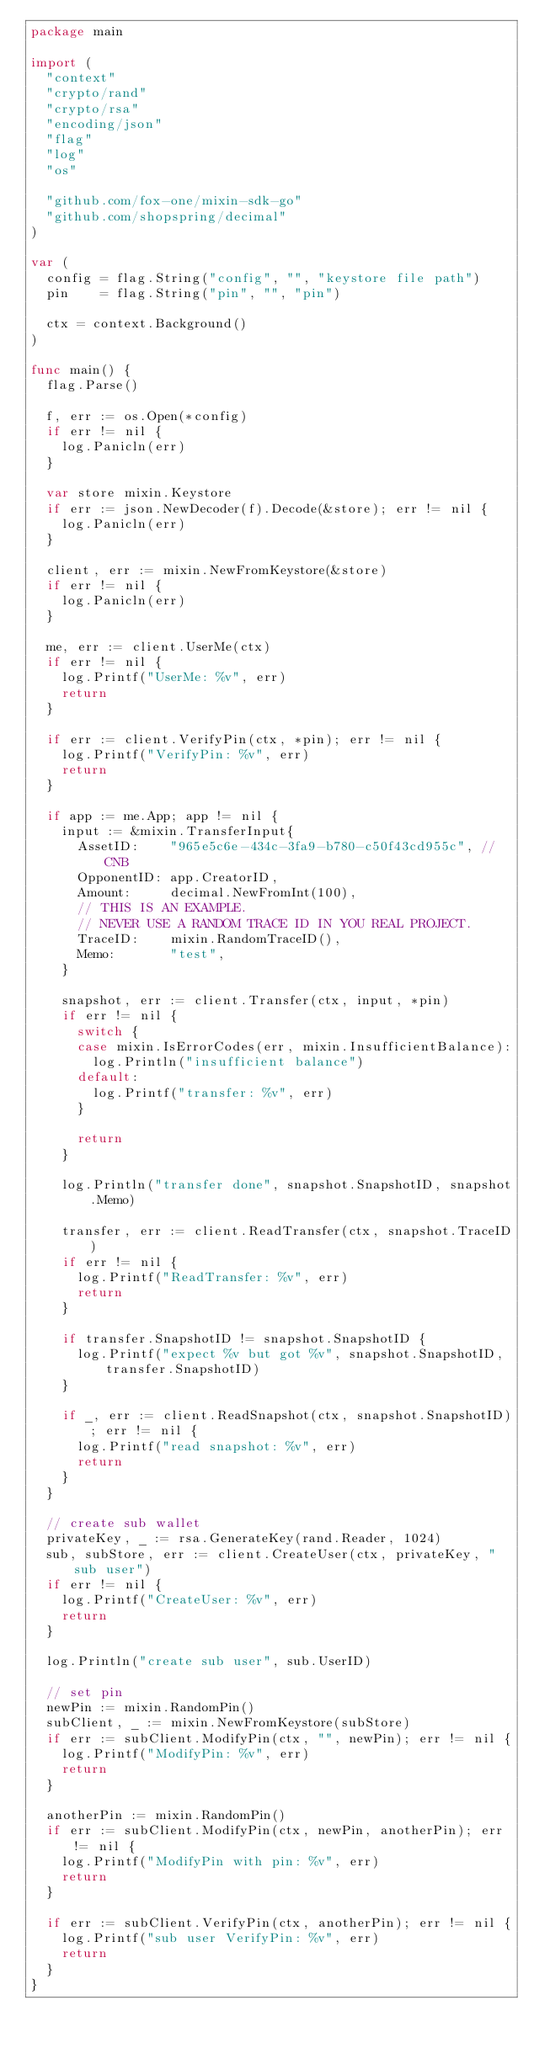<code> <loc_0><loc_0><loc_500><loc_500><_Go_>package main

import (
	"context"
	"crypto/rand"
	"crypto/rsa"
	"encoding/json"
	"flag"
	"log"
	"os"

	"github.com/fox-one/mixin-sdk-go"
	"github.com/shopspring/decimal"
)

var (
	config = flag.String("config", "", "keystore file path")
	pin    = flag.String("pin", "", "pin")

	ctx = context.Background()
)

func main() {
	flag.Parse()

	f, err := os.Open(*config)
	if err != nil {
		log.Panicln(err)
	}

	var store mixin.Keystore
	if err := json.NewDecoder(f).Decode(&store); err != nil {
		log.Panicln(err)
	}

	client, err := mixin.NewFromKeystore(&store)
	if err != nil {
		log.Panicln(err)
	}

	me, err := client.UserMe(ctx)
	if err != nil {
		log.Printf("UserMe: %v", err)
		return
	}

	if err := client.VerifyPin(ctx, *pin); err != nil {
		log.Printf("VerifyPin: %v", err)
		return
	}

	if app := me.App; app != nil {
		input := &mixin.TransferInput{
			AssetID:    "965e5c6e-434c-3fa9-b780-c50f43cd955c", // CNB
			OpponentID: app.CreatorID,
			Amount:     decimal.NewFromInt(100),
			// THIS IS AN EXAMPLE.
			// NEVER USE A RANDOM TRACE ID IN YOU REAL PROJECT.
			TraceID:    mixin.RandomTraceID(),
			Memo:       "test",
		}

		snapshot, err := client.Transfer(ctx, input, *pin)
		if err != nil {
			switch {
			case mixin.IsErrorCodes(err, mixin.InsufficientBalance):
				log.Println("insufficient balance")
			default:
				log.Printf("transfer: %v", err)
			}

			return
		}

		log.Println("transfer done", snapshot.SnapshotID, snapshot.Memo)

		transfer, err := client.ReadTransfer(ctx, snapshot.TraceID)
		if err != nil {
			log.Printf("ReadTransfer: %v", err)
			return
		}

		if transfer.SnapshotID != snapshot.SnapshotID {
			log.Printf("expect %v but got %v", snapshot.SnapshotID, transfer.SnapshotID)
		}

		if _, err := client.ReadSnapshot(ctx, snapshot.SnapshotID); err != nil {
			log.Printf("read snapshot: %v", err)
			return
		}
	}

	// create sub wallet
	privateKey, _ := rsa.GenerateKey(rand.Reader, 1024)
	sub, subStore, err := client.CreateUser(ctx, privateKey, "sub user")
	if err != nil {
		log.Printf("CreateUser: %v", err)
		return
	}

	log.Println("create sub user", sub.UserID)

	// set pin
	newPin := mixin.RandomPin()
	subClient, _ := mixin.NewFromKeystore(subStore)
	if err := subClient.ModifyPin(ctx, "", newPin); err != nil {
		log.Printf("ModifyPin: %v", err)
		return
	}

	anotherPin := mixin.RandomPin()
	if err := subClient.ModifyPin(ctx, newPin, anotherPin); err != nil {
		log.Printf("ModifyPin with pin: %v", err)
		return
	}

	if err := subClient.VerifyPin(ctx, anotherPin); err != nil {
		log.Printf("sub user VerifyPin: %v", err)
		return
	}
}
</code> 